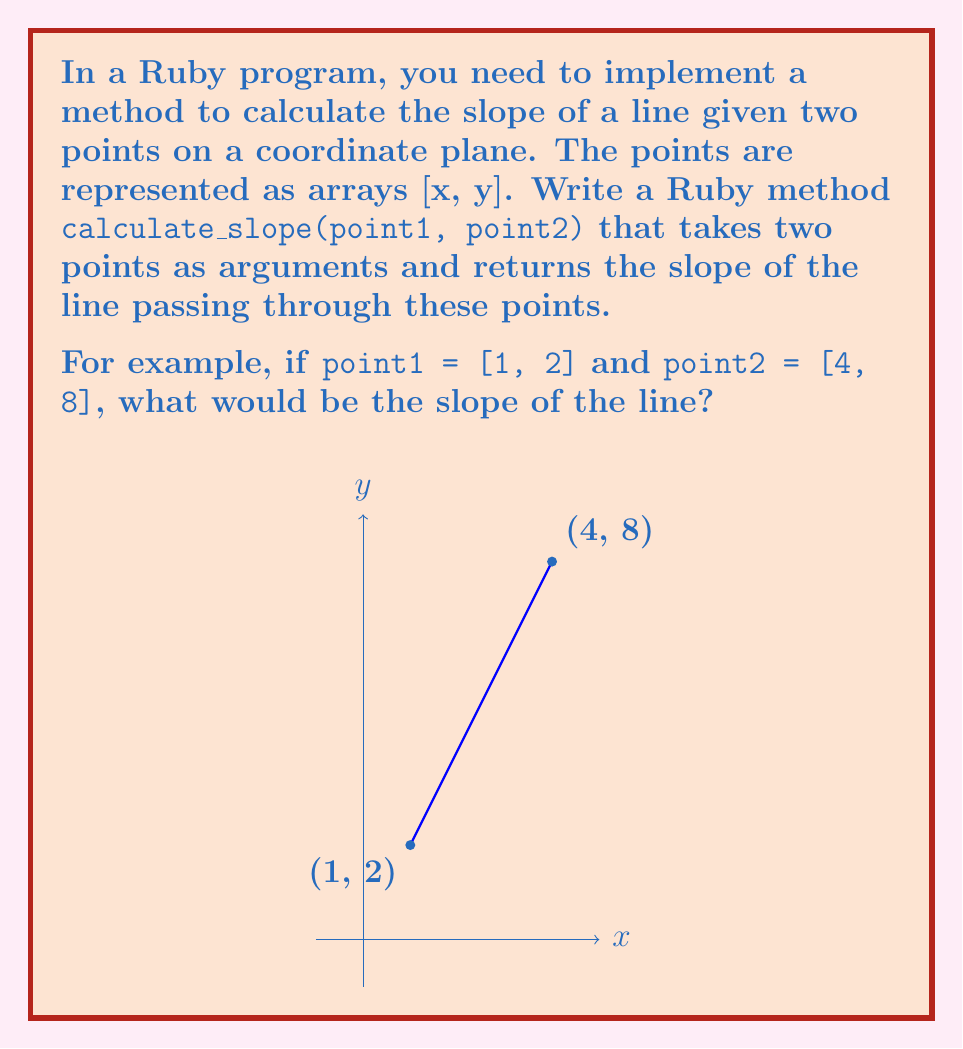Help me with this question. To calculate the slope of a line given two points, we use the slope formula:

$$ m = \frac{y_2 - y_1}{x_2 - x_1} $$

Where $(x_1, y_1)$ is the first point and $(x_2, y_2)$ is the second point.

Let's implement this in Ruby:

```ruby
def calculate_slope(point1, point2)
  x1, y1 = point1
  x2, y2 = point2
  
  rise = y2 - y1
  run = x2 - x1
  
  rise.to_f / run
end
```

Now, let's apply this to our example:

1. We have `point1 = [1, 2]` and `point2 = [4, 8]`
2. Extracting coordinates:
   $x_1 = 1$, $y_1 = 2$
   $x_2 = 4$, $y_2 = 8$
3. Calculate rise: $y_2 - y_1 = 8 - 2 = 6$
4. Calculate run: $x_2 - x_1 = 4 - 1 = 3$
5. Calculate slope: $m = \frac{rise}{run} = \frac{6}{3} = 2$

Therefore, the slope of the line passing through points (1, 2) and (4, 8) is 2.
Answer: 2 